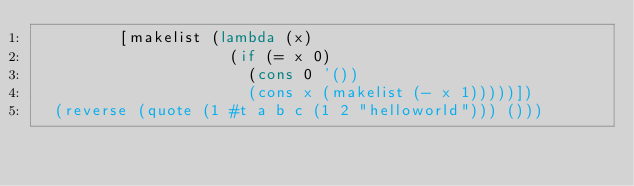Convert code to text. <code><loc_0><loc_0><loc_500><loc_500><_Scheme_>         [makelist (lambda (x)
                     (if (= x 0)
                       (cons 0 '())
                       (cons x (makelist (- x 1)))))])
  (reverse (quote (1 #t a b c (1 2 "helloworld"))) ()))
</code> 